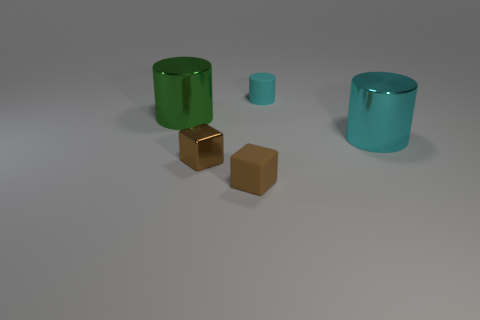Is the small shiny block the same color as the tiny rubber block?
Ensure brevity in your answer.  Yes. How many other objects are the same color as the tiny rubber cylinder?
Provide a succinct answer. 1. Is the color of the big cylinder that is to the right of the large green metal object the same as the tiny matte cylinder?
Your answer should be compact. Yes. What is the size of the other cylinder that is the same color as the tiny cylinder?
Give a very brief answer. Large. Do the green cylinder and the big cyan cylinder have the same material?
Your answer should be very brief. Yes. The other matte object that is the same size as the cyan rubber object is what color?
Provide a succinct answer. Brown. What number of other things are there of the same shape as the large green object?
Provide a succinct answer. 2. There is a green object; is its size the same as the metal thing in front of the large cyan object?
Keep it short and to the point. No. What number of things are either cylinders or big brown metal cylinders?
Provide a short and direct response. 3. How many other objects are the same size as the brown matte block?
Provide a short and direct response. 2. 